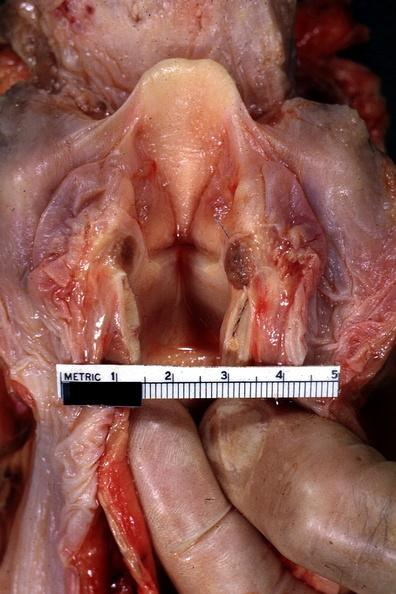does this image show opened larynx shows quite well?
Answer the question using a single word or phrase. Yes 